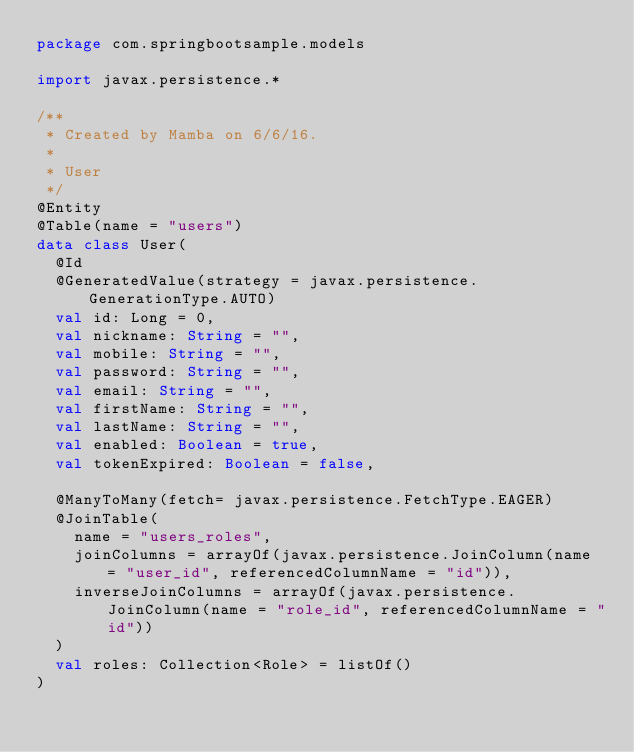<code> <loc_0><loc_0><loc_500><loc_500><_Kotlin_>package com.springbootsample.models

import javax.persistence.*

/**
 * Created by Mamba on 6/6/16.
 *
 * User
 */
@Entity
@Table(name = "users")
data class User(
  @Id
  @GeneratedValue(strategy = javax.persistence.GenerationType.AUTO)
  val id: Long = 0,
  val nickname: String = "",
  val mobile: String = "",
  val password: String = "",
  val email: String = "",
  val firstName: String = "",
  val lastName: String = "",
  val enabled: Boolean = true,
  val tokenExpired: Boolean = false,

  @ManyToMany(fetch= javax.persistence.FetchType.EAGER)
  @JoinTable(
    name = "users_roles",
    joinColumns = arrayOf(javax.persistence.JoinColumn(name = "user_id", referencedColumnName = "id")),
    inverseJoinColumns = arrayOf(javax.persistence.JoinColumn(name = "role_id", referencedColumnName = "id"))
  )
  val roles: Collection<Role> = listOf()
)
</code> 